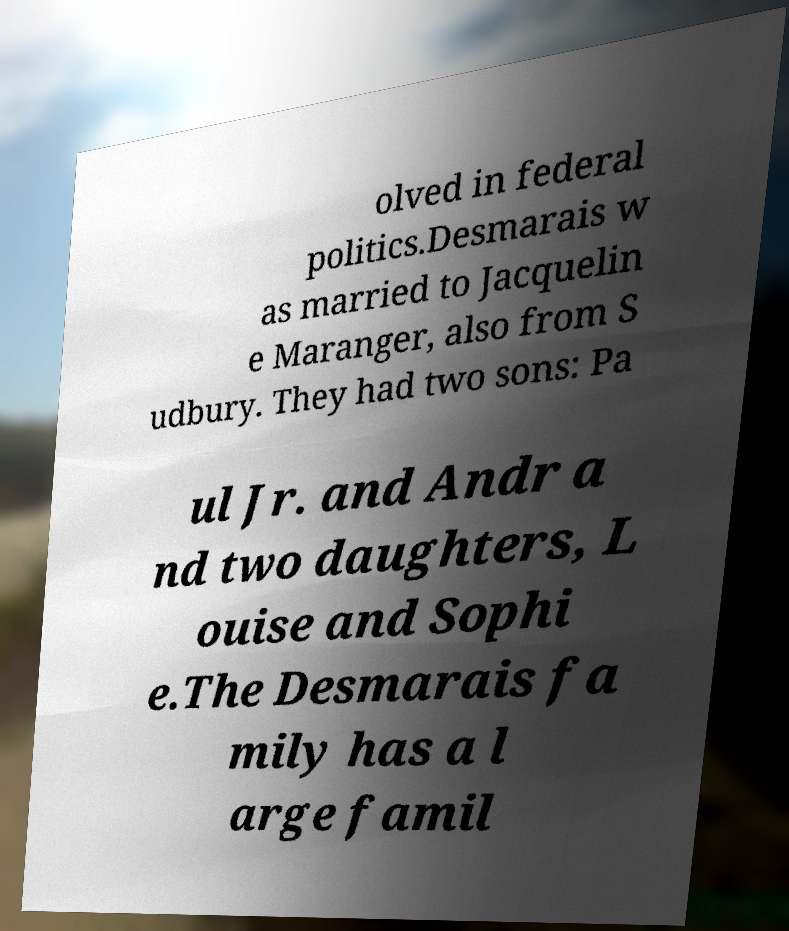Can you accurately transcribe the text from the provided image for me? olved in federal politics.Desmarais w as married to Jacquelin e Maranger, also from S udbury. They had two sons: Pa ul Jr. and Andr a nd two daughters, L ouise and Sophi e.The Desmarais fa mily has a l arge famil 